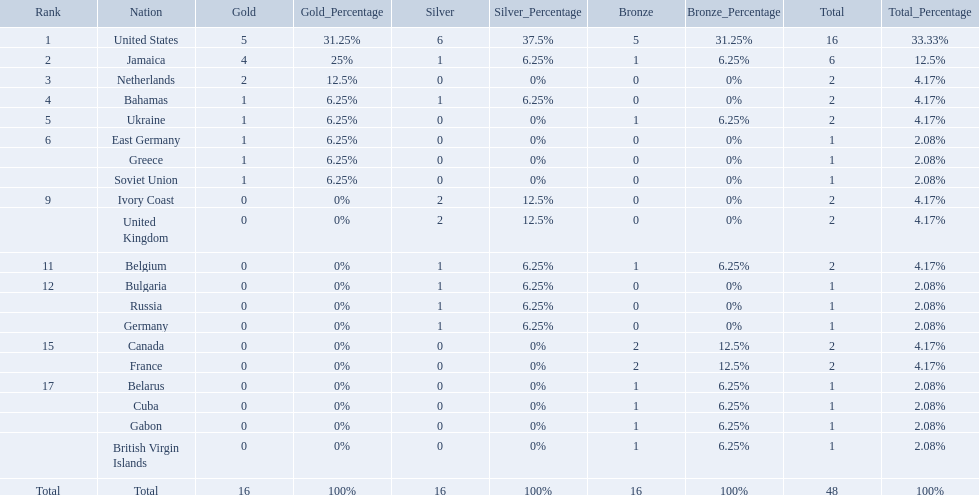What was the largest number of medals won by any country? 16. Which country won that many medals? United States. Which countries participated? United States, Jamaica, Netherlands, Bahamas, Ukraine, East Germany, Greece, Soviet Union, Ivory Coast, United Kingdom, Belgium, Bulgaria, Russia, Germany, Canada, France, Belarus, Cuba, Gabon, British Virgin Islands. How many gold medals were won by each? 5, 4, 2, 1, 1, 1, 1, 1, 0, 0, 0, 0, 0, 0, 0, 0, 0, 0, 0, 0. And which country won the most? United States. Which nations took home at least one gold medal in the 60 metres competition? United States, Jamaica, Netherlands, Bahamas, Ukraine, East Germany, Greece, Soviet Union. Of these nations, which one won the most gold medals? United States. What country won the most medals? United States. How many medals did the us win? 16. What is the most medals (after 16) that were won by a country? 6. Which country won 6 medals? Jamaica. 